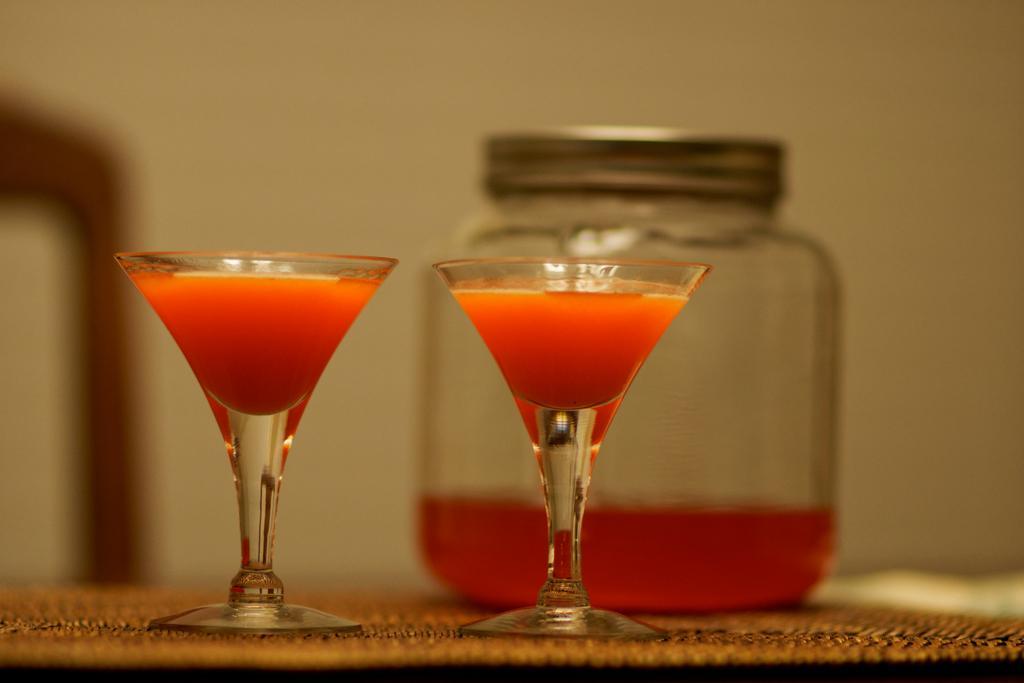Can you describe this image briefly? In the image there are two glasses filled with some drink and behind the glasses trees a jar closed with a lid. 